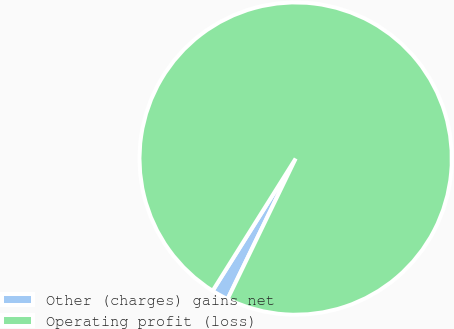Convert chart to OTSL. <chart><loc_0><loc_0><loc_500><loc_500><pie_chart><fcel>Other (charges) gains net<fcel>Operating profit (loss)<nl><fcel>1.74%<fcel>98.26%<nl></chart> 